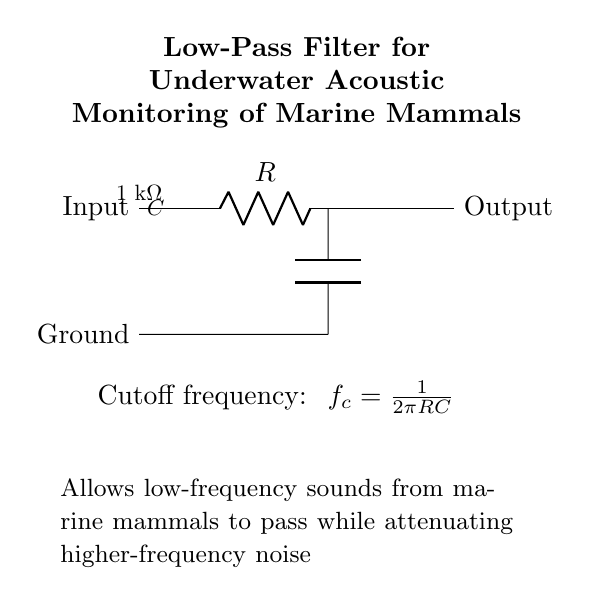What is the resistance value in this circuit? The circuit diagram labels a resistor with a value of 1 kΩ, which is a standard unit of resistance.
Answer: 1 kΩ What does the capacitor do in this filter? The capacitor in a low-pass filter allows low-frequency signals to pass while blocking higher-frequency signals, which is essential for monitoring marine mammal sounds.
Answer: Attenuates high frequencies What is the cutoff frequency formula provided? The formula for the cutoff frequency written in the circuit is \( f_c = \frac{1}{2\pi RC} \), which defines the frequency at which the output signal is reduced to 70.7% of the input signal.
Answer: f_c = 1/(2πRC) What does the arrow direction indicate about the circuit connections? The arrows indicate the direction of signal flow from the input through the components to the output, showing how the signal is processed in the filter.
Answer: Signal flow direction Which part of the circuit is connected to ground? The lower terminal of the capacitor is connected to the ground, which serves as a reference point for the electrical potential in the circuit.
Answer: Capacitor What is the purpose of this low-pass filter in marine monitoring? The purpose is to filter out higher-frequency noise, allowing only low-frequency acoustic signals from marine mammals to be captured, which is crucial for effective monitoring and conservation.
Answer: Monitor marine mammals 